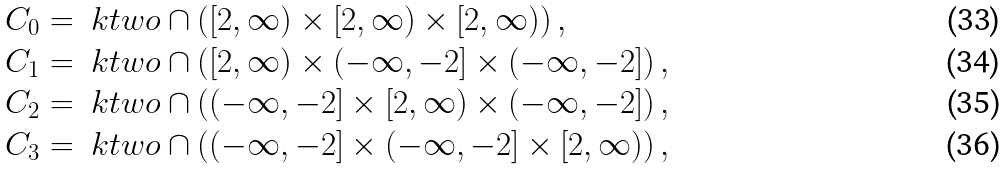<formula> <loc_0><loc_0><loc_500><loc_500>C _ { 0 } & = \ k t w o \cap \left ( [ 2 , \infty ) \times [ 2 , \infty ) \times [ 2 , \infty ) \right ) , \\ C _ { 1 } & = \ k t w o \cap \left ( [ 2 , \infty ) \times ( - \infty , - 2 ] \times ( - \infty , - 2 ] \right ) , \\ C _ { 2 } & = \ k t w o \cap \left ( ( - \infty , - 2 ] \times [ 2 , \infty ) \times ( - \infty , - 2 ] \right ) , \\ C _ { 3 } & = \ k t w o \cap \left ( ( - \infty , - 2 ] \times ( - \infty , - 2 ] \times [ 2 , \infty ) \right ) ,</formula> 